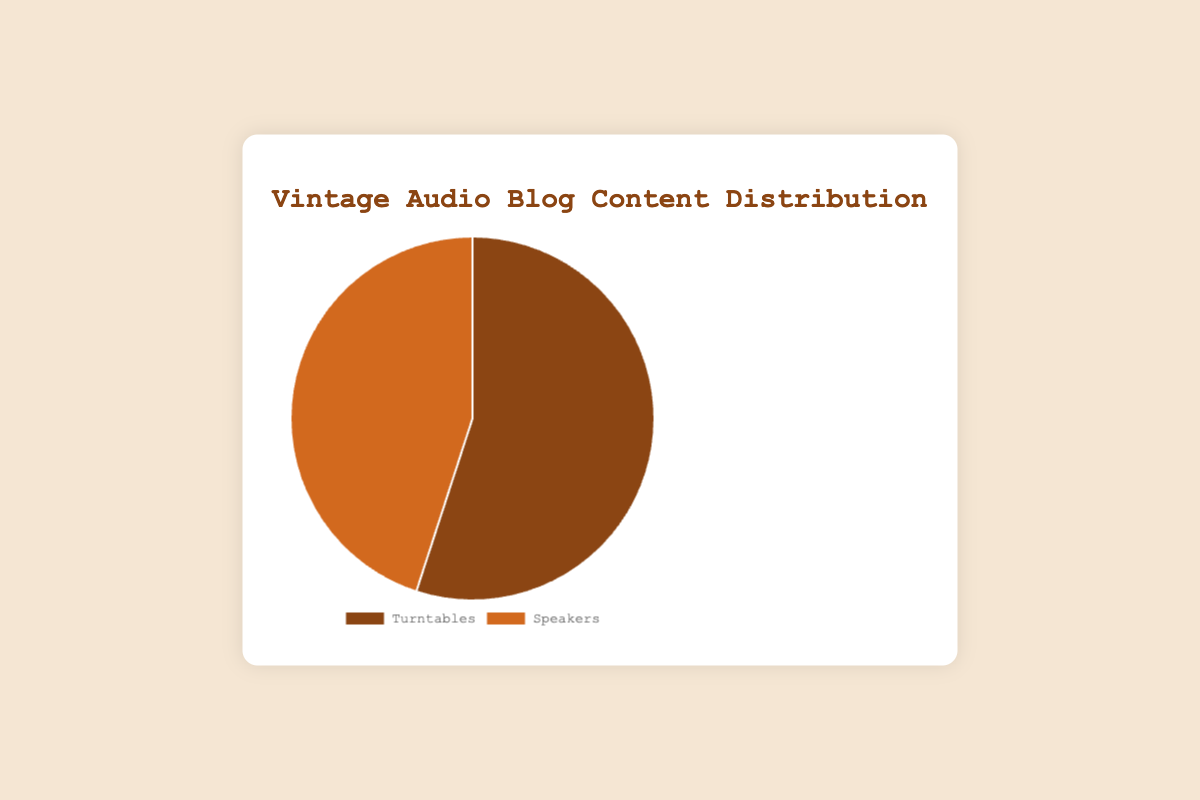What's the percentage share of the blog content focused on turntables? The pie chart shows that the portion labeled "Turntables" corresponds to 55%, which is the specified share of blog content focused on turntables.
Answer: 55% What's the percentage difference between blog content focused on turntables and speakers? Turntables make up 55% of the content, while speakers account for 45%. The difference is calculated as 55% - 45% = 10%.
Answer: 10% Which category has a larger share of blog content, turntables or speakers? Comparing the values from the chart, turntables have a larger share with 55% compared to speakers at 45%.
Answer: Turntables If the blog were to add more content to equalize the share between turntables and speakers, by what percentage should the speaker content be increased? To equalize both categories at 50%, we need to decrease turntable content by 5% and increase speaker content by 5%. Since speakers are at 45%, the increase is calculated as 5% more of the total 100%.
Answer: 5% Considering the proportions, if you read 100 blog posts, how many would you expect to be about speakers? 45% of 100 blog posts can be calculated as 0.45 * 100 = 45 posts.
Answer: 45 posts What is the total percentage of content dedicated to audio equipment? Both turntables and speakers together make up 100% of the blog content, as identified in the pie chart.
Answer: 100% By how much does the turntable content exceed the speaker content in percentage points? The turntable content percentage (55%) minus the speaker content percentage (45%) gives 10 percentage points.
Answer: 10 percentage points What colors are used to represent turntables and speakers in the pie chart? The chart uses brown-like shades for turntables and a lighter orange shade for speakers, easily identifiable by their distinct colors.
Answer: Brown for turntables, orange for speakers 